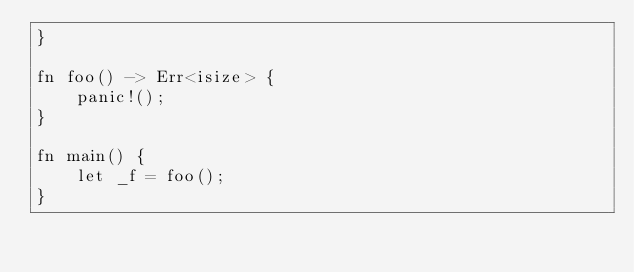<code> <loc_0><loc_0><loc_500><loc_500><_Rust_>}

fn foo() -> Err<isize> {
    panic!();
}

fn main() {
    let _f = foo();
}
</code> 